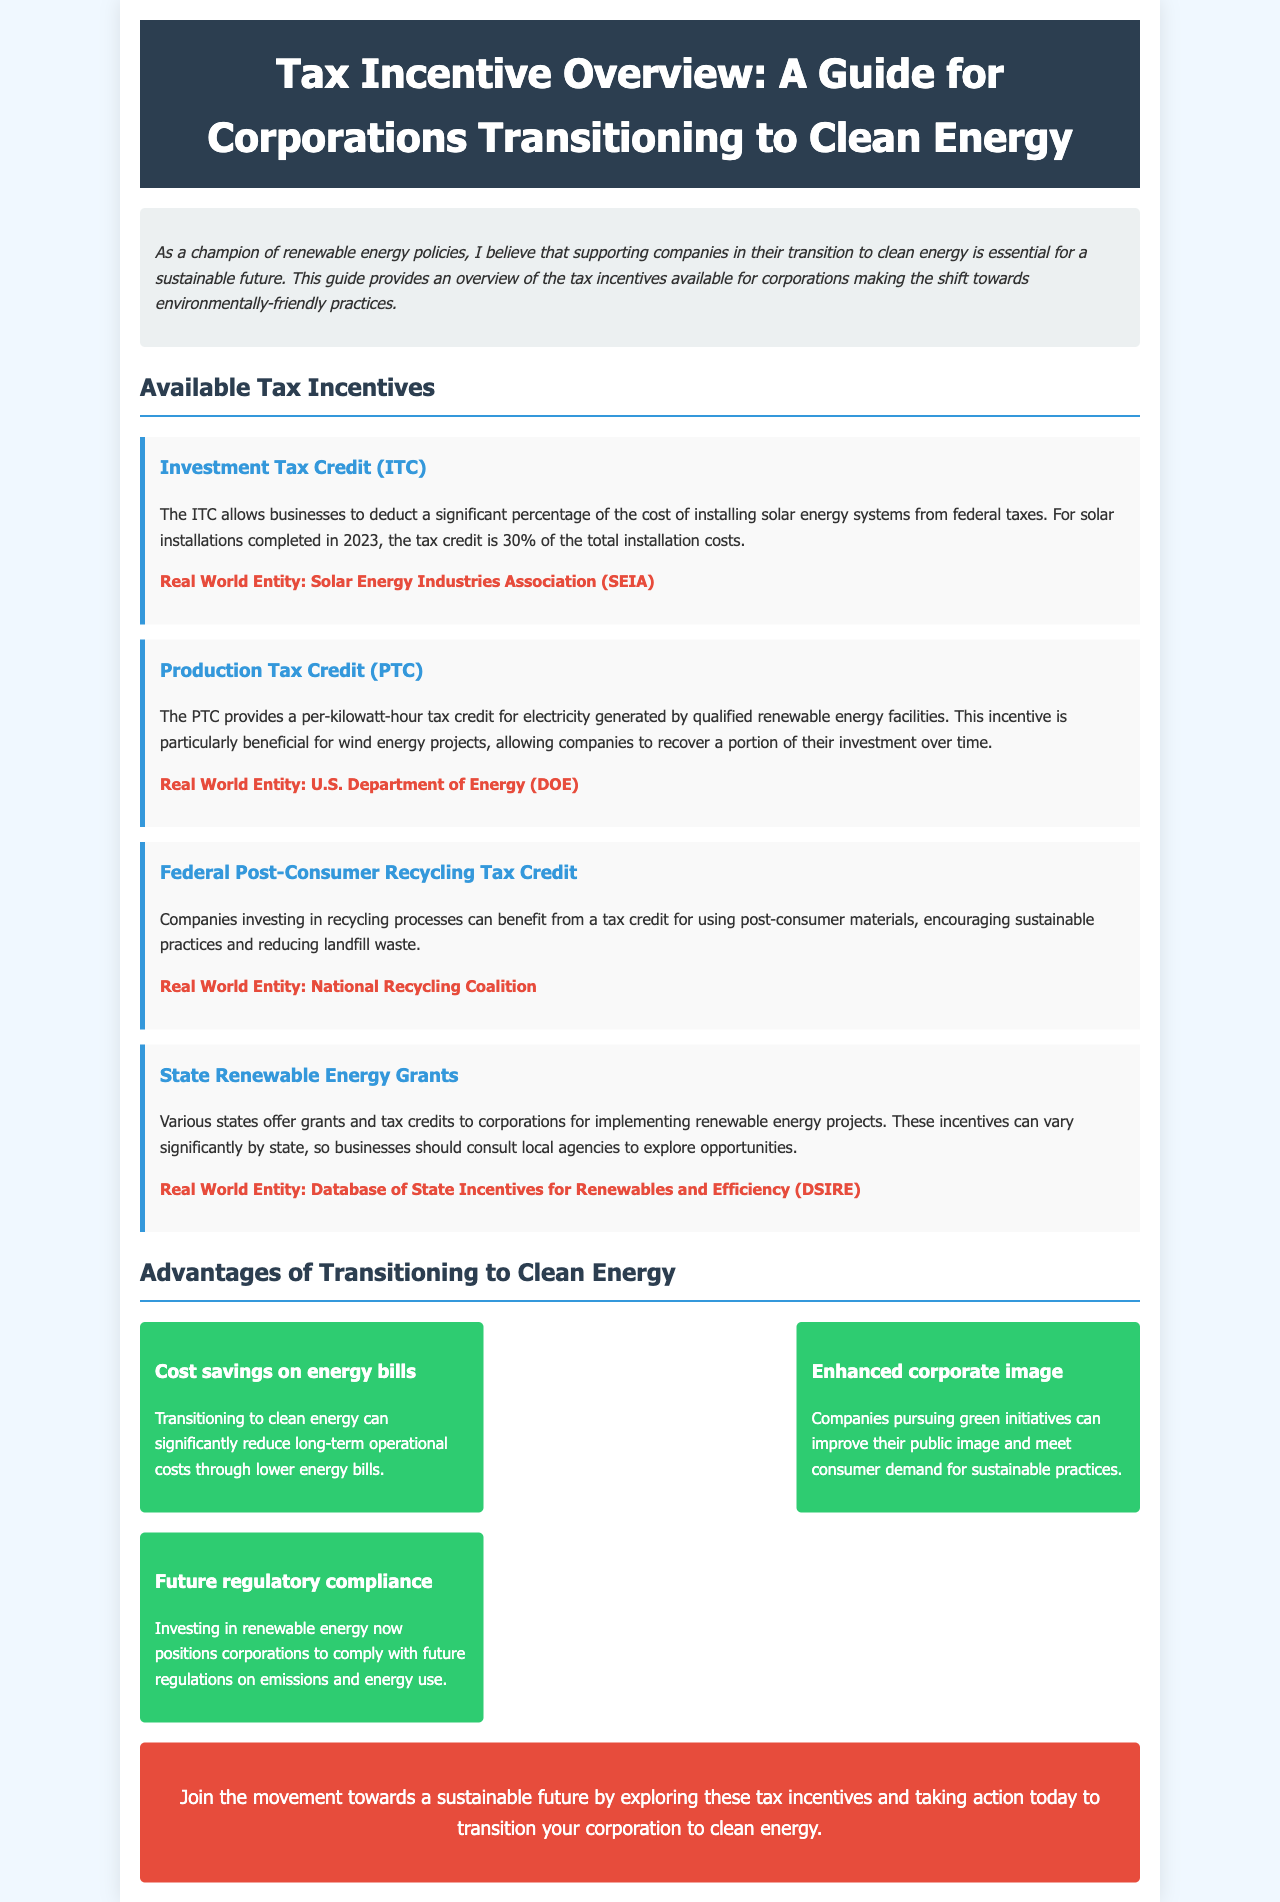What is the tax credit percentage for solar installations in 2023? The document states that the tax credit for solar installations completed in 2023 is 30% of the total installation costs.
Answer: 30% What does PTC stand for? In the document, PTC is referred to as the Production Tax Credit.
Answer: Production Tax Credit Which organization is associated with the Investment Tax Credit? The document mentions the Solar Energy Industries Association (SEIA) as the real-world entity related to the Investment Tax Credit.
Answer: Solar Energy Industries Association (SEIA) What is one advantage of transitioning to clean energy mentioned in the document? The document lists several advantages including cost savings on energy bills, enhanced corporate image, and future regulatory compliance.
Answer: Cost savings on energy bills What type of tax credit encourages the use of post-consumer materials? The document refers to the Federal Post-Consumer Recycling Tax Credit as a tax credit that encourages using post-consumer materials.
Answer: Federal Post-Consumer Recycling Tax Credit What should businesses consult to explore state grants? The document suggests businesses consult local agencies to explore opportunities related to state grants.
Answer: Local agencies What color is used for the background of the document? The background color of the document is specified as light blue (#f0f8ff).
Answer: Light blue What is the call to action at the end of the document? The call to action encourages exploring tax incentives and taking action to transition to clean energy.
Answer: Explore tax incentives and take action to transition to clean energy 